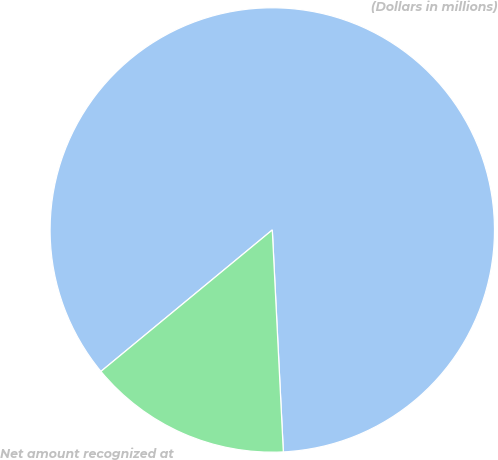Convert chart. <chart><loc_0><loc_0><loc_500><loc_500><pie_chart><fcel>(Dollars in millions)<fcel>Net amount recognized at<nl><fcel>85.19%<fcel>14.81%<nl></chart> 